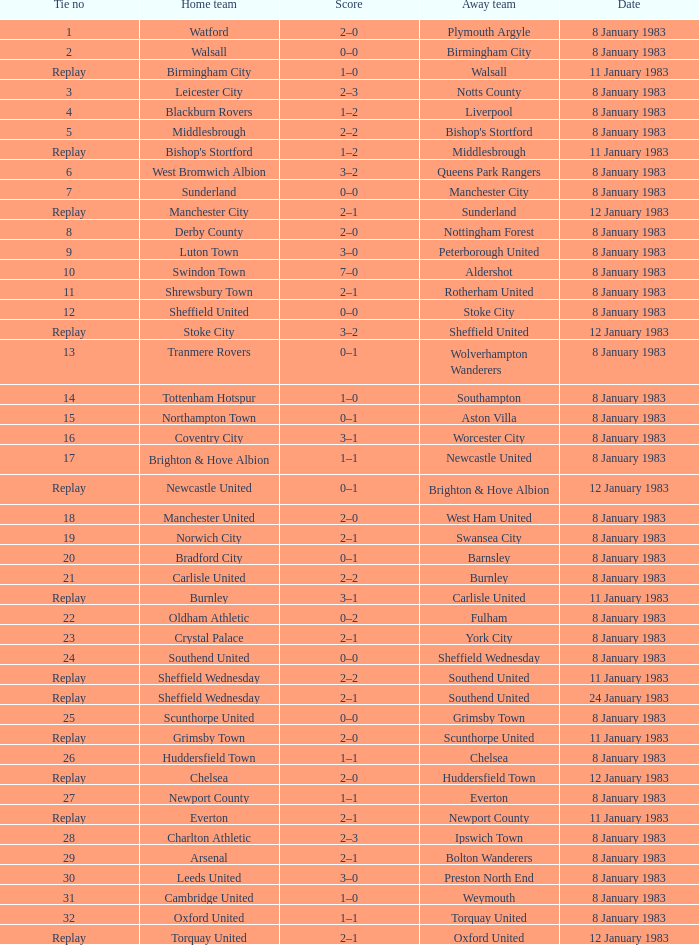What is the name of the away team for Tie #19? Swansea City. 